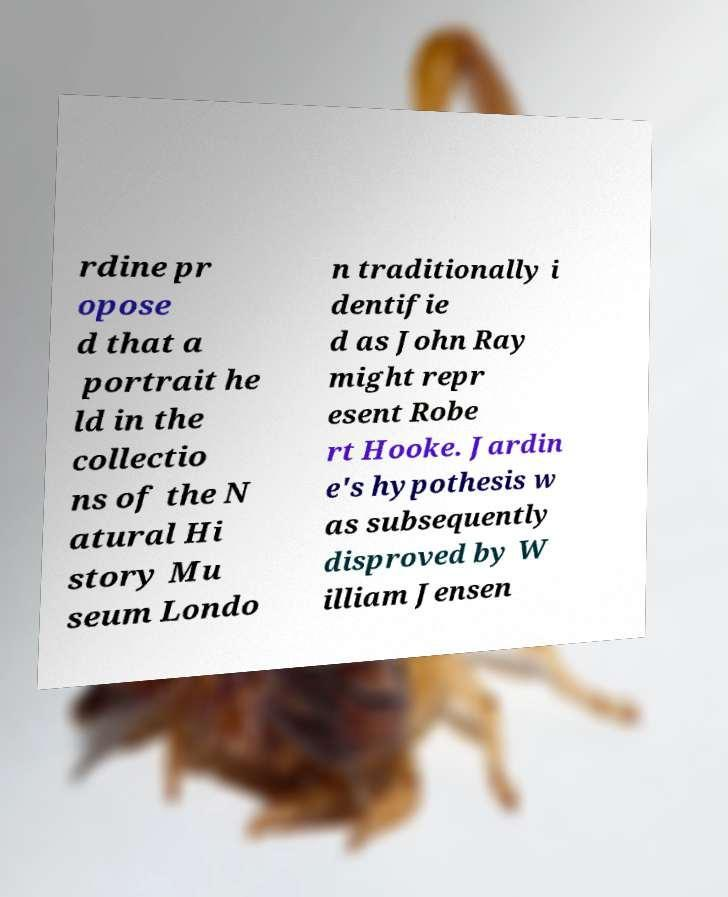I need the written content from this picture converted into text. Can you do that? rdine pr opose d that a portrait he ld in the collectio ns of the N atural Hi story Mu seum Londo n traditionally i dentifie d as John Ray might repr esent Robe rt Hooke. Jardin e's hypothesis w as subsequently disproved by W illiam Jensen 